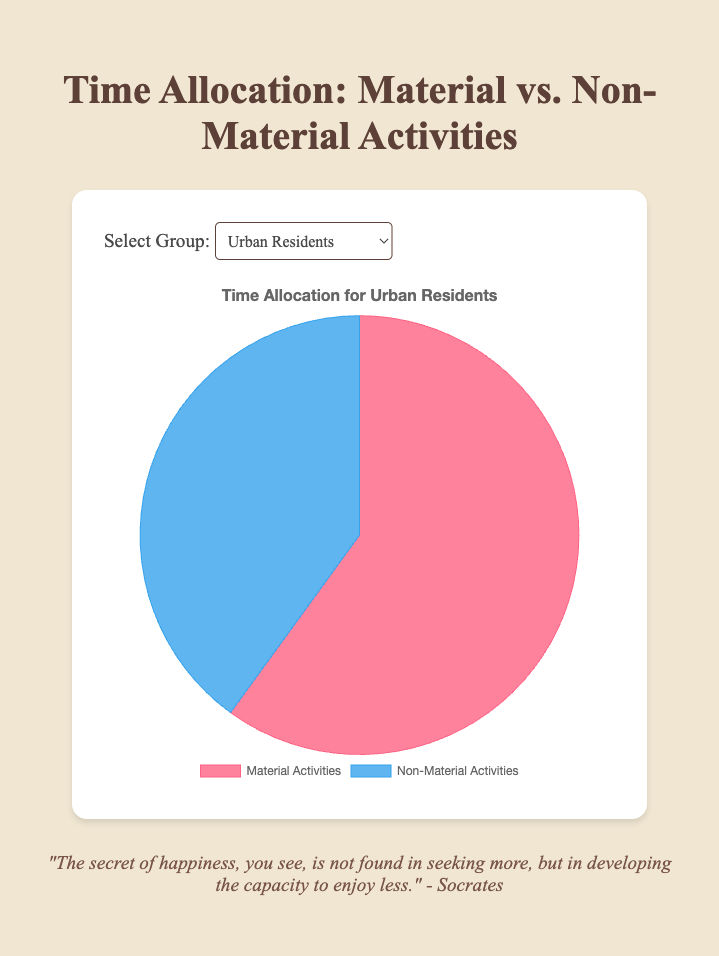What proportion of time do Urban Residents spend on Material Activities? Urban Residents spend 60% of their time on Material Activities, as seen in their segment of the pie chart.
Answer: 60% How do Freelancers distribute their time between Material and Non-Material Activities? Comparing the two segments for Freelancers, each occupies equal spaces in the pie chart, indicating they spend 50% of their time on Material Activities and 50% on Non-Material Activities.
Answer: 50% on each Which group spends the greatest proportion of their time on Non-Material Activities? By comparing the sizes of the segments across all the pie charts, Retirees have the largest segment for Non-Material Activities, which is 70%.
Answer: Retirees What is the difference in the proportion of time spent on Material Activities between Corporate Employees and Rural Residents? Corporate Employees spend 70% of their time on Material Activities while Rural Residents spend 40% on Material Activities. The difference is 70% - 40% = 30%.
Answer: 30% Is there a group that spends equal time on Material and Non-Material Activities? Reviewing the pie charts, Freelancers have equal segments for Material and Non-Material Activities, each being 50%.
Answer: Yes, Freelancers Which color represents Non-Material Activities, and how can you tell? Non-Material Activities are represented in blue, which appears distinctly in the respective segments of all groups’ pie charts.
Answer: Blue How much more time do Urban Residents spend on Material Activities compared to Non-Material Activities? Urban Residents spend 60% on Material Activities and 40% on Non-Material Activities. The difference is 60% - 40% = 20%.
Answer: 20% Do Corporate Employees spend more time on Material Activities compared to Urban Residents? Corporate Employees spend 70% on Material Activities, whereas Urban Residents spend 60%. Therefore, Corporate Employees indeed spend more time on Material Activities than Urban Residents.
Answer: Yes What is the average proportion of time spent on Non-Material Activities by all groups combined? Summing the percentages of Non-Material Activities: (40% Urban Residents + 60% Rural Residents + 30% Corporate Employees + 50% Freelancers + 70% Retirees) = 250%. There are 5 groups, so the average is 250% / 5 = 50%.
Answer: 50% Do Rural Residents spend a greater proportion of their time on Non-Material Activities compared to Urban Residents? Rural Residents spend 60% on Non-Material Activities, whereas Urban Residents spend 40%. Therefore, Rural Residents spend more time on Non-Material Activities.
Answer: Yes 